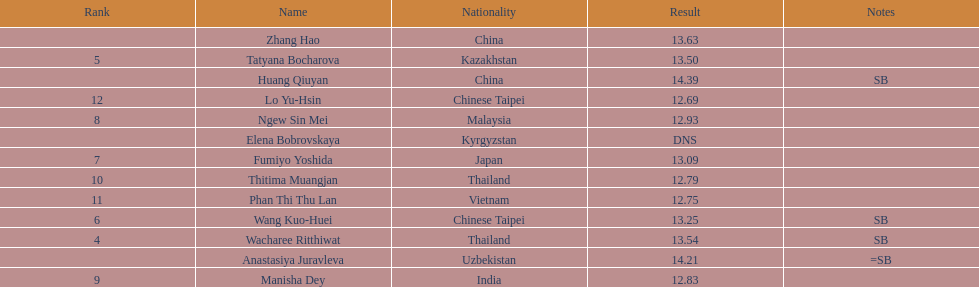Parse the full table. {'header': ['Rank', 'Name', 'Nationality', 'Result', 'Notes'], 'rows': [['', 'Zhang Hao', 'China', '13.63', ''], ['5', 'Tatyana Bocharova', 'Kazakhstan', '13.50', ''], ['', 'Huang Qiuyan', 'China', '14.39', 'SB'], ['12', 'Lo Yu-Hsin', 'Chinese Taipei', '12.69', ''], ['8', 'Ngew Sin Mei', 'Malaysia', '12.93', ''], ['', 'Elena Bobrovskaya', 'Kyrgyzstan', 'DNS', ''], ['7', 'Fumiyo Yoshida', 'Japan', '13.09', ''], ['10', 'Thitima Muangjan', 'Thailand', '12.79', ''], ['11', 'Phan Thi Thu Lan', 'Vietnam', '12.75', ''], ['6', 'Wang Kuo-Huei', 'Chinese Taipei', '13.25', 'SB'], ['4', 'Wacharee Ritthiwat', 'Thailand', '13.54', 'SB'], ['', 'Anastasiya Juravleva', 'Uzbekistan', '14.21', '=SB'], ['9', 'Manisha Dey', 'India', '12.83', '']]} What was the average result of the top three jumpers? 14.08. 